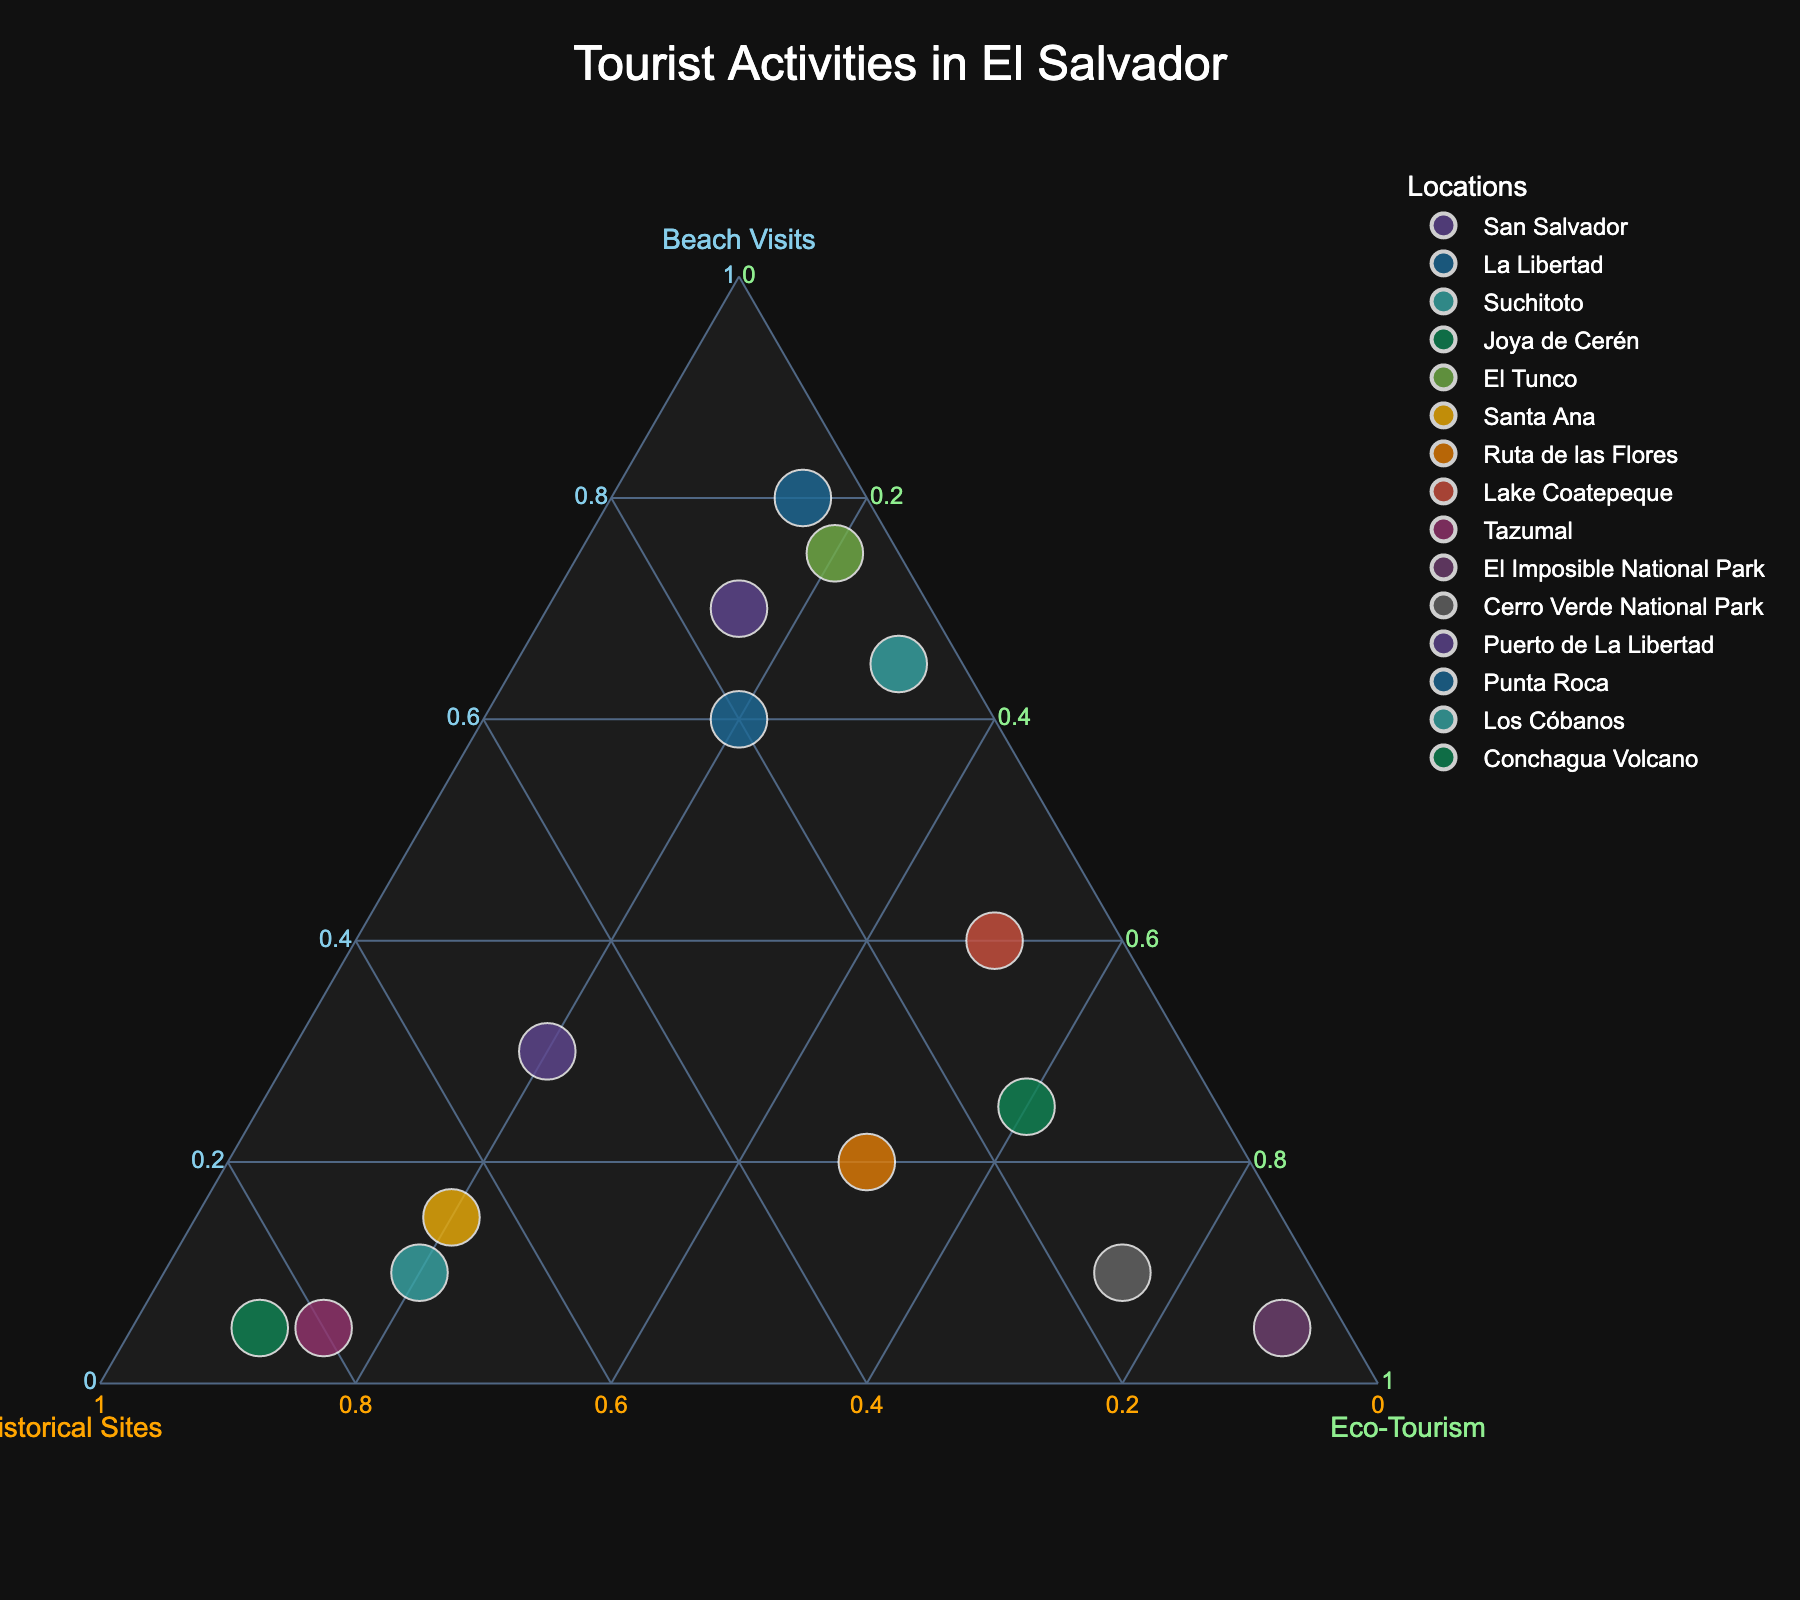Which location has the highest proportion of beach visits? By examining the ternary plot, the point located closest to the "Beach Visits" axis represents a location with the highest proportion of beach visits.
Answer: Punta Roca What is the title of the plot? The title of the plot is displayed at the top center of the figure.
Answer: Tourist Activities in El Salvador How many locations are represented in the plot? Count the number of distinct points or data markers in the ternary plot.
Answer: 15 Which location devotes equal attention to beach visits, historical sites, and eco-tourism? Look for a point that is equally distant from each of the three axes. However, none of the points lie exactly at the center.
Answer: None Which locations have the highest proportion devoted to eco-tourism? Check for points positioned closest to the "Eco-Tourism" axis.
Answer: El Imposible National Park, Cerro Verde National Park Which location shows a more balanced distribution among all three activities? Find a point that is centrally placed with respect to the three axes but not necessarily at the center.
Answer: Conchagua Volcano What is the approximate percentage composition of activities in San Salvador? Locate San Salvador's point and estimate its position relative to the three axes.
Answer: ~30% Beach Visits, ~50% Historical Sites, ~20% Eco-Tourism Which location has more historical sites than beach visits? Find points that are closer to the "Historical Sites" axis compared to the "Beach Visits" axis.
Answer: San Salvador, Suchitoto, Joya de Cerén, Santa Ana, Tazumal What is the relative proportion of beach visits to eco-tourism in El Tunco? Locate El Tunco and compare its distances from the "Beach Visits" axis and the "Eco-Tourism" axis.
Answer: 75% Beach Visits, 20% Eco-Tourism Compare the eco-tourism focus between Ruta de las Flores and Lake Coatepeque. Identify the points for both locations and compare their distances to the "Eco-Tourism" axis.
Answer: Ruta de las Flores: 50%, Lake Coatepeque: 50% 